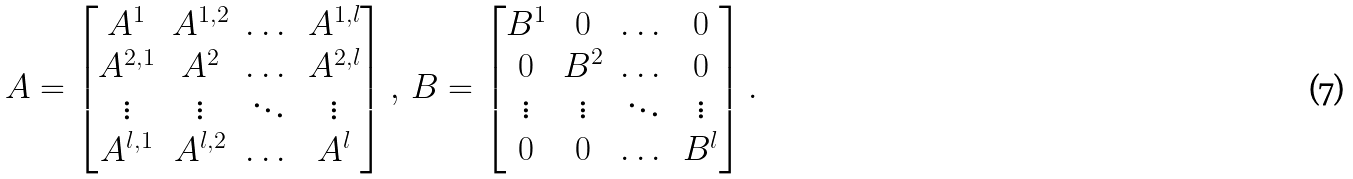Convert formula to latex. <formula><loc_0><loc_0><loc_500><loc_500>A = \begin{bmatrix} A ^ { 1 } & A ^ { 1 , 2 } & \dots & A ^ { 1 , l } \\ A ^ { 2 , 1 } & A ^ { 2 } & \dots & A ^ { 2 , l } \\ \vdots & \vdots & \ddots & \vdots \\ A ^ { l , 1 } & A ^ { l , 2 } & \dots & A ^ { l } \end{bmatrix} , \, B = \begin{bmatrix} B ^ { 1 } & 0 & \dots & 0 \\ 0 & B ^ { 2 } & \dots & 0 \\ \vdots & \vdots & \ddots & \vdots \\ 0 & 0 & \dots & B ^ { l } \end{bmatrix} .</formula> 